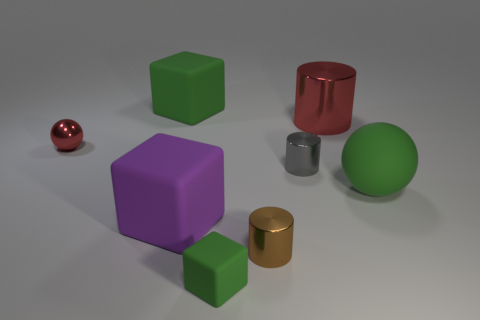Add 1 big purple things. How many objects exist? 9 Subtract all cylinders. How many objects are left? 5 Subtract 0 yellow balls. How many objects are left? 8 Subtract all big green metal cubes. Subtract all small shiny things. How many objects are left? 5 Add 3 red metallic balls. How many red metallic balls are left? 4 Add 3 small blue cubes. How many small blue cubes exist? 3 